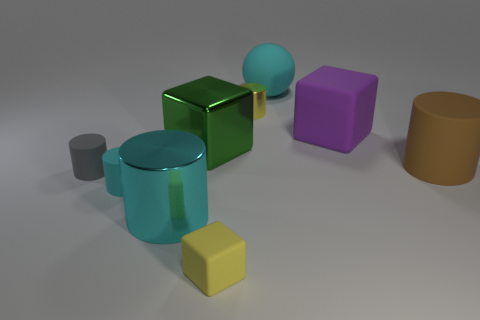Does the green block have the same size as the yellow metallic thing?
Your response must be concise. No. What number of cylinders are tiny gray matte objects or matte things?
Give a very brief answer. 3. How many large cyan objects are both to the left of the green metal object and behind the small cyan cylinder?
Keep it short and to the point. 0. There is a cyan matte sphere; does it have the same size as the matte cube that is in front of the big purple matte object?
Provide a short and direct response. No. There is a rubber cylinder to the right of the rubber thing that is in front of the small cyan matte cylinder; are there any big cyan objects that are in front of it?
Provide a short and direct response. Yes. There is a thing behind the shiny object to the right of the small rubber cube; what is its material?
Ensure brevity in your answer.  Rubber. What material is the cyan object that is in front of the big rubber block and to the right of the tiny cyan thing?
Offer a very short reply. Metal. Are there any purple rubber objects that have the same shape as the big green metallic thing?
Provide a short and direct response. Yes. Is there a large object left of the cyan matte object behind the gray cylinder?
Ensure brevity in your answer.  Yes. How many tiny yellow things have the same material as the small yellow cylinder?
Your response must be concise. 0. 